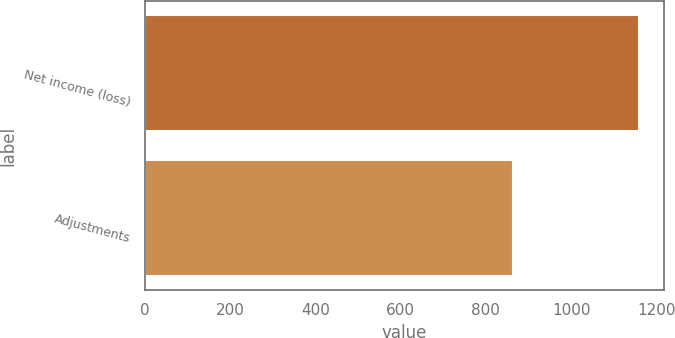Convert chart to OTSL. <chart><loc_0><loc_0><loc_500><loc_500><bar_chart><fcel>Net income (loss)<fcel>Adjustments<nl><fcel>1160<fcel>864<nl></chart> 